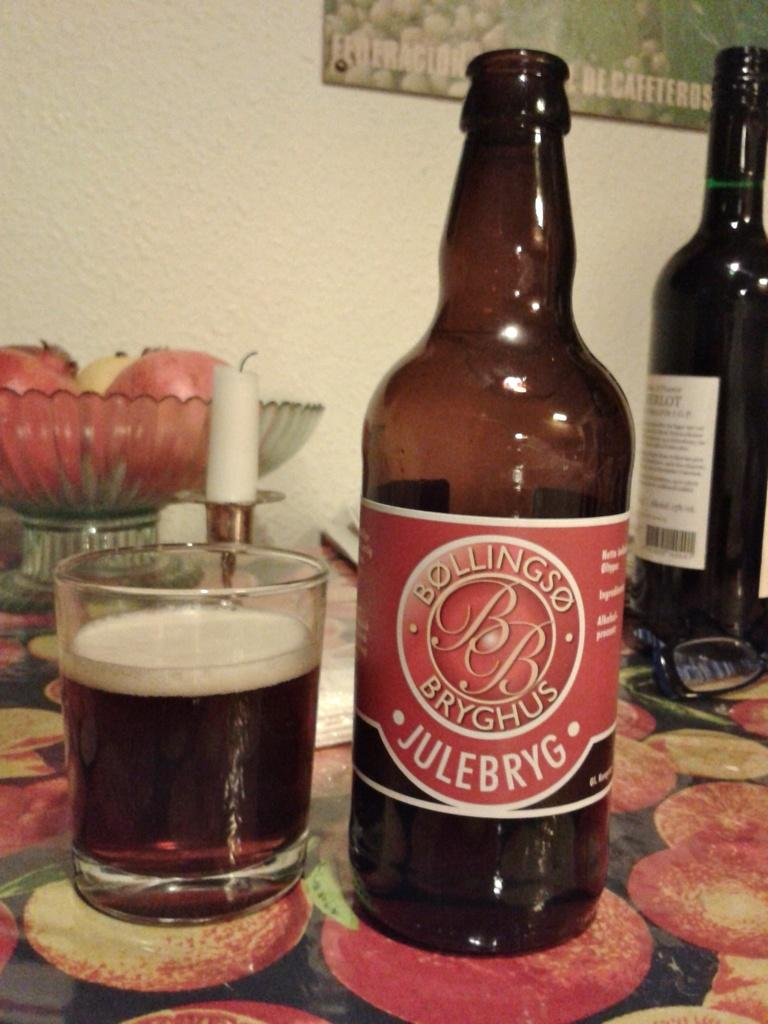Provide a one-sentence caption for the provided image. A bottle of Bollings Julebryg beer sits on a table with a fruit. 